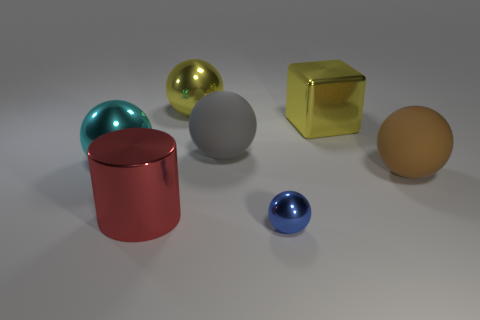How many things are either purple cylinders or gray rubber balls?
Your answer should be very brief. 1. There is a matte object that is on the left side of the big yellow object that is right of the rubber object that is to the left of the large brown matte object; what is its size?
Provide a short and direct response. Large. What number of shiny spheres have the same color as the tiny metal object?
Make the answer very short. 0. What number of large yellow blocks have the same material as the red thing?
Your answer should be compact. 1. How many things are either big metal cylinders or spheres that are to the right of the tiny metal sphere?
Your response must be concise. 2. There is a big ball behind the rubber sphere that is behind the matte ball in front of the cyan ball; what is its color?
Offer a very short reply. Yellow. There is a yellow block that is behind the big gray thing; how big is it?
Your response must be concise. Large. What number of big objects are metallic cubes or brown matte cylinders?
Ensure brevity in your answer.  1. There is a metal object that is right of the big gray sphere and in front of the cyan shiny ball; what color is it?
Provide a succinct answer. Blue. Are there any other large rubber things of the same shape as the large red thing?
Your answer should be very brief. No. 